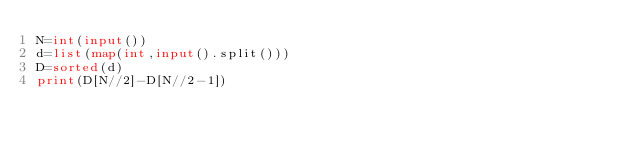<code> <loc_0><loc_0><loc_500><loc_500><_Python_>N=int(input())
d=list(map(int,input().split()))
D=sorted(d)
print(D[N//2]-D[N//2-1])</code> 